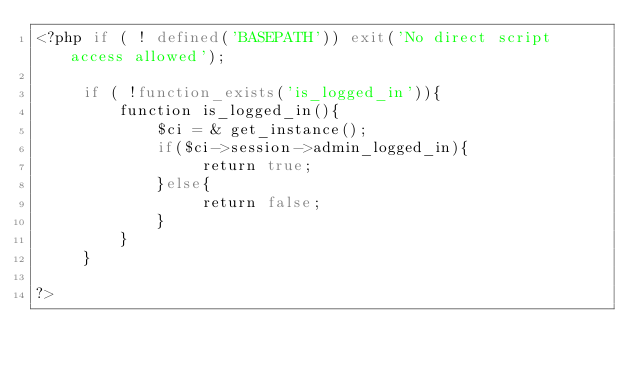Convert code to text. <code><loc_0><loc_0><loc_500><loc_500><_PHP_><?php if ( ! defined('BASEPATH')) exit('No direct script access allowed');

     if ( !function_exists('is_logged_in')){
         function is_logged_in(){
             $ci = & get_instance();
             if($ci->session->admin_logged_in){
                  return true;
             }else{
                  return false;
             }
         }
     }

?>
</code> 